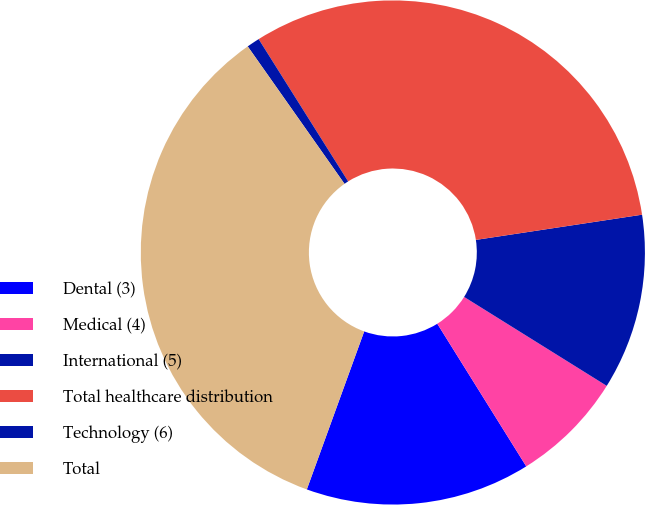<chart> <loc_0><loc_0><loc_500><loc_500><pie_chart><fcel>Dental (3)<fcel>Medical (4)<fcel>International (5)<fcel>Total healthcare distribution<fcel>Technology (6)<fcel>Total<nl><fcel>14.42%<fcel>7.25%<fcel>11.27%<fcel>31.54%<fcel>0.83%<fcel>34.69%<nl></chart> 